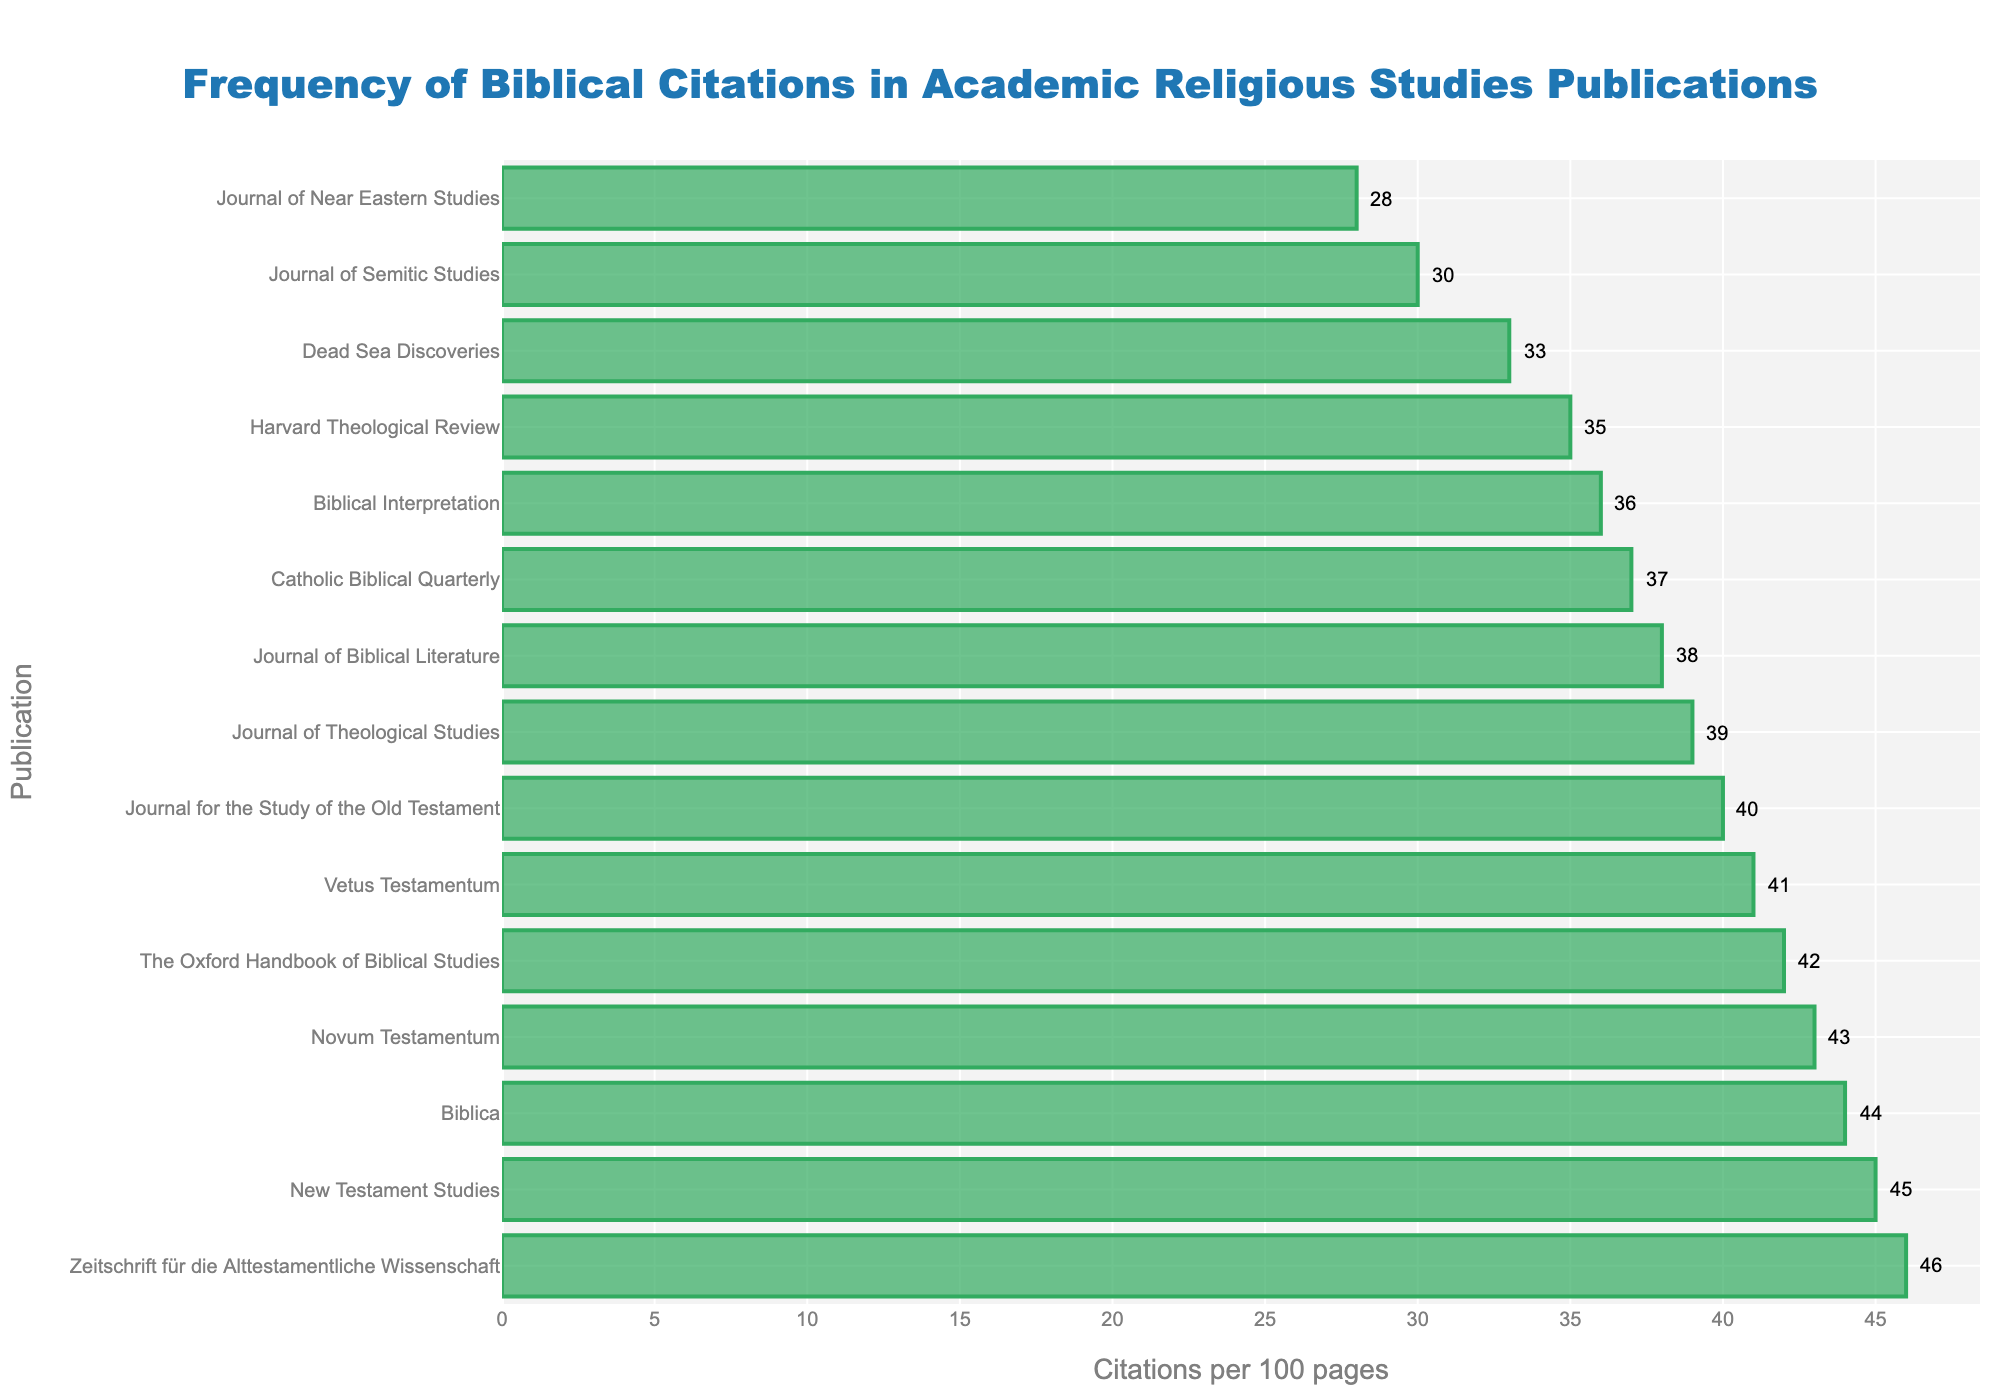Which publication has the highest frequency of biblical citations? The tallest bar corresponds to "Zeitschrift für die Alttestamentliche Wissenschaft" with 46 citations per 100 pages.
Answer: Zeitschrift für die Alttestamentliche Wissenschaft What are the top three publications in terms of biblical citations frequency? The three tallest bars represent "Zeitschrift für die Alttestamentliche Wissenschaft" (46), "New Testament Studies" (45), and "Biblica" (44).
Answer: Zeitschrift für die Alttestamentliche Wissenschaft, New Testament Studies, Biblica What is the difference in citation frequency between "Biblical Interpretation" and "Journal of Near Eastern Studies"? "Biblical Interpretation" has 36 citations per 100 pages, and "Journal of Near Eastern Studies" has 28. The difference is 36 - 28 = 8.
Answer: 8 Which publications have a citation frequency greater than 40? Publications with bars extending beyond 40 citations per 100 pages are "Zeitschrift für die Alttestamentliche Wissenschaft" (46), "New Testament Studies" (45), "Biblica" (44), and "Novum Testamentum" (43).
Answer: Zeitschrift für die Alttestamentliche Wissenschaft, New Testament Studies, Biblica, Novum Testamentum What is the average citation frequency across all publications? Sum all citation frequencies and divide by the number of publications. Total Sum = 42 + 38 + 35 + 45 + 40 + 37 + 41 + 43 + 36 + 39 + 44 + 33 + 30 + 28 + 46 = 577. Number of publications = 15. Average = 577 / 15 ≈ 38.47.
Answer: 38.47 How does the citation frequency of "Catholic Biblical Quarterly" compare to "Harvard Theological Review"? "Catholic Biblical Quarterly" has 37 citations per 100 pages, while "Harvard Theological Review" has 35. Therefore, "Catholic Biblical Quarterly" has 2 more citations per 100 pages than "Harvard Theological Review".
Answer: 2 more Which publication is closest to the median citation frequency? Sort citation frequencies: 28, 30, 33, 35, 36, 37, 38, 39, 40, 41, 42, 43, 44, 45, 46. The median is the middle value, which is the 8th value: 39. "Journal of Theological Studies" has 39 citations per 100 pages.
Answer: Journal of Theological Studies How many publications have citation frequencies less than or equal to 35? Publications with bars no taller than 35 citations per 100 pages include "Harvard Theological Review" (35), "Dead Sea Discoveries" (33), "Journal of Semitic Studies" (30), and "Journal of Near Eastern Studies" (28). There are 4 such publications.
Answer: 4 What is the citation frequency range of the displayed publications? The maximum citation frequency is 46 (Zeitschrift für die Alttestamentliche Wissenschaft) and the minimum is 28 (Journal of Near Eastern Studies). The range is 46 - 28 = 18.
Answer: 18 How does the length of the bar for "Novum Testamentum" compare visually to that of "Vetus Testamentum"? "Novum Testamentum" has a citation frequency of 43, while "Vetus Testamentum" has 41. Visually, the bar for "Novum Testamentum" is slightly longer than that of "Vetus Testamentum".
Answer: Slightly longer 